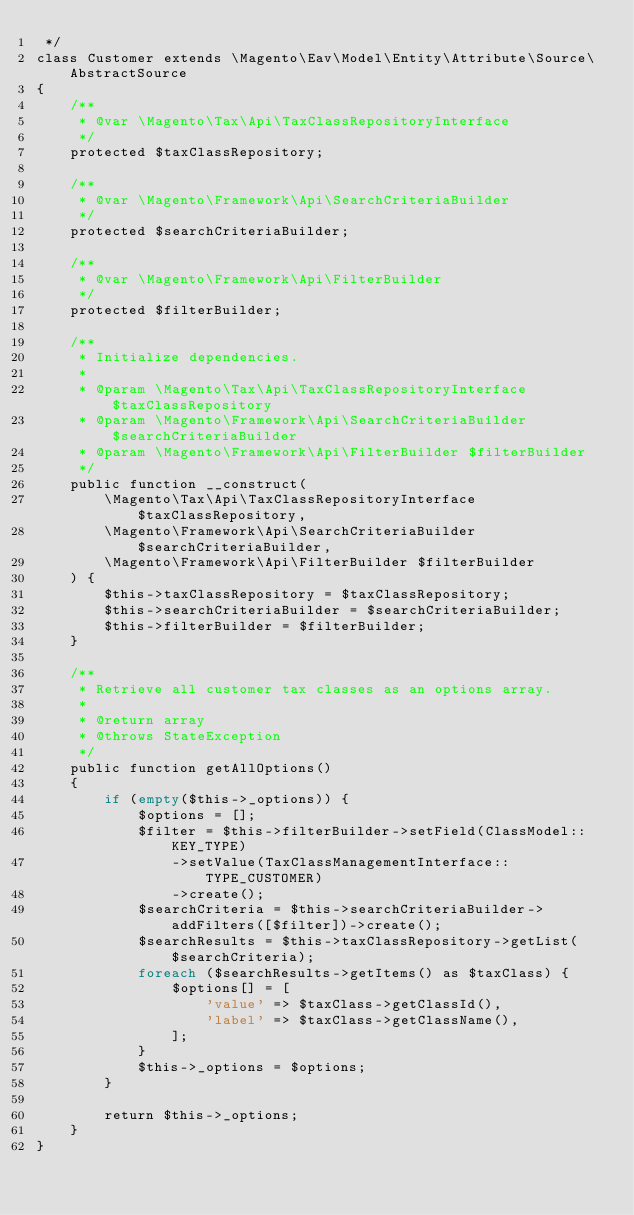<code> <loc_0><loc_0><loc_500><loc_500><_PHP_> */
class Customer extends \Magento\Eav\Model\Entity\Attribute\Source\AbstractSource
{
    /**
     * @var \Magento\Tax\Api\TaxClassRepositoryInterface
     */
    protected $taxClassRepository;

    /**
     * @var \Magento\Framework\Api\SearchCriteriaBuilder
     */
    protected $searchCriteriaBuilder;

    /**
     * @var \Magento\Framework\Api\FilterBuilder
     */
    protected $filterBuilder;

    /**
     * Initialize dependencies.
     *
     * @param \Magento\Tax\Api\TaxClassRepositoryInterface $taxClassRepository
     * @param \Magento\Framework\Api\SearchCriteriaBuilder $searchCriteriaBuilder
     * @param \Magento\Framework\Api\FilterBuilder $filterBuilder
     */
    public function __construct(
        \Magento\Tax\Api\TaxClassRepositoryInterface $taxClassRepository,
        \Magento\Framework\Api\SearchCriteriaBuilder $searchCriteriaBuilder,
        \Magento\Framework\Api\FilterBuilder $filterBuilder
    ) {
        $this->taxClassRepository = $taxClassRepository;
        $this->searchCriteriaBuilder = $searchCriteriaBuilder;
        $this->filterBuilder = $filterBuilder;
    }

    /**
     * Retrieve all customer tax classes as an options array.
     *
     * @return array
     * @throws StateException
     */
    public function getAllOptions()
    {
        if (empty($this->_options)) {
            $options = [];
            $filter = $this->filterBuilder->setField(ClassModel::KEY_TYPE)
                ->setValue(TaxClassManagementInterface::TYPE_CUSTOMER)
                ->create();
            $searchCriteria = $this->searchCriteriaBuilder->addFilters([$filter])->create();
            $searchResults = $this->taxClassRepository->getList($searchCriteria);
            foreach ($searchResults->getItems() as $taxClass) {
                $options[] = [
                    'value' => $taxClass->getClassId(),
                    'label' => $taxClass->getClassName(),
                ];
            }
            $this->_options = $options;
        }

        return $this->_options;
    }
}
</code> 